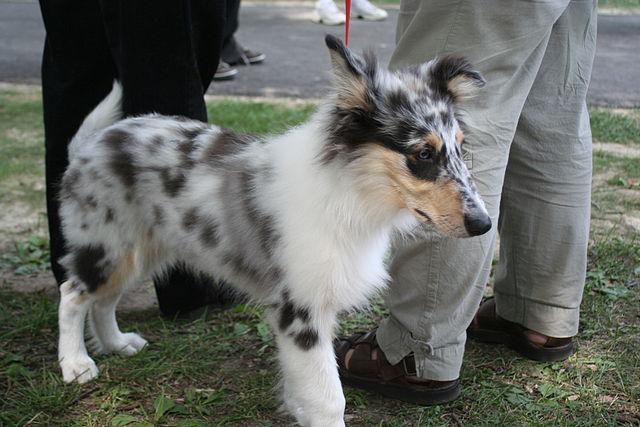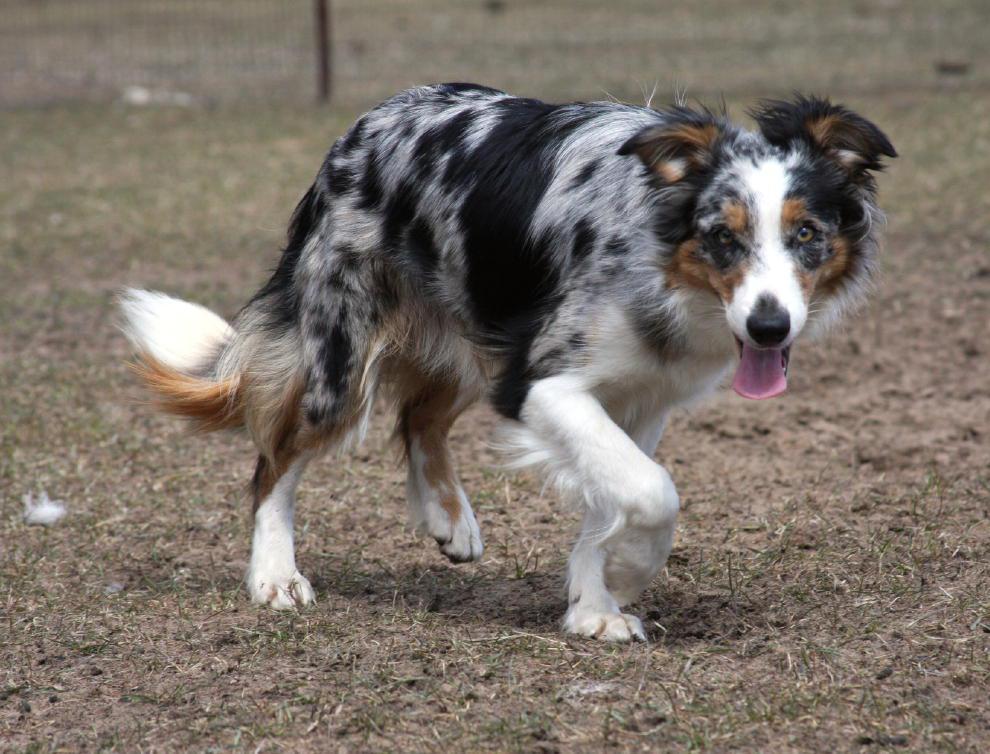The first image is the image on the left, the second image is the image on the right. Considering the images on both sides, is "A dog has its mouth open and showing its tongue." valid? Answer yes or no. Yes. The first image is the image on the left, the second image is the image on the right. Considering the images on both sides, is "One image shows a spotted puppy in a non-standing position, with both front paws extended." valid? Answer yes or no. No. 